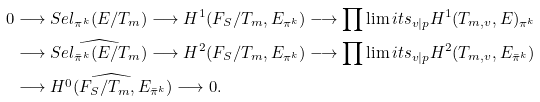<formula> <loc_0><loc_0><loc_500><loc_500>0 & \longrightarrow { S e l } _ { \pi ^ { k } } ( E / T _ { m } ) \longrightarrow { H ^ { 1 } ( F _ { S } / T _ { m } , E _ { \pi ^ { k } } ) } \longrightarrow { \prod \lim i t s _ { v | p } H ^ { 1 } ( T _ { m , v } , E ) _ { \pi ^ { k } } } \\ & \longrightarrow \widehat { { S e l } _ { \bar { \pi } ^ { k } } ( E / T _ { m } ) } \longrightarrow { H ^ { 2 } ( F _ { S } / T _ { m } , E _ { \pi ^ { k } } ) } \longrightarrow { \prod \lim i t s _ { v | p } H ^ { 2 } ( T _ { m , v } , E _ { \bar { \pi } ^ { k } } ) } \\ & \longrightarrow \widehat { H ^ { 0 } ( F _ { S } / T _ { m } , E _ { \bar { \pi } ^ { k } } ) } \longrightarrow 0 .</formula> 